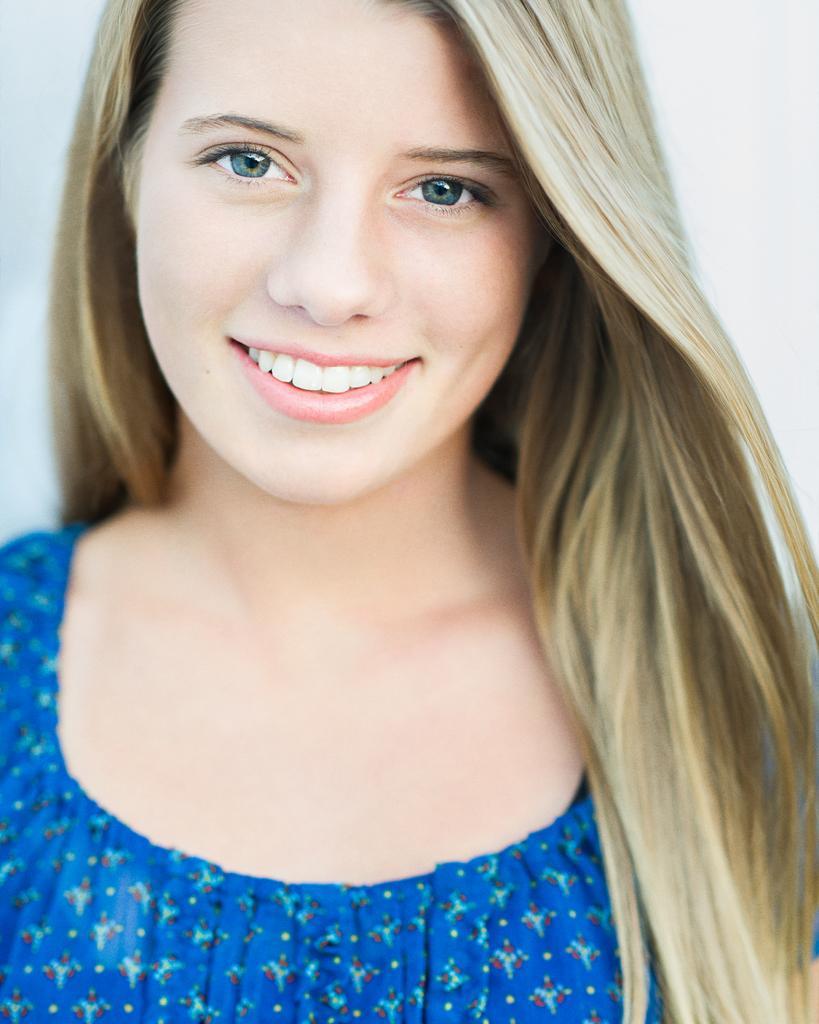How would you summarize this image in a sentence or two? In the center of the image we can see one woman smiling, which we can see on her face. And we can see she is in a blue color top. 